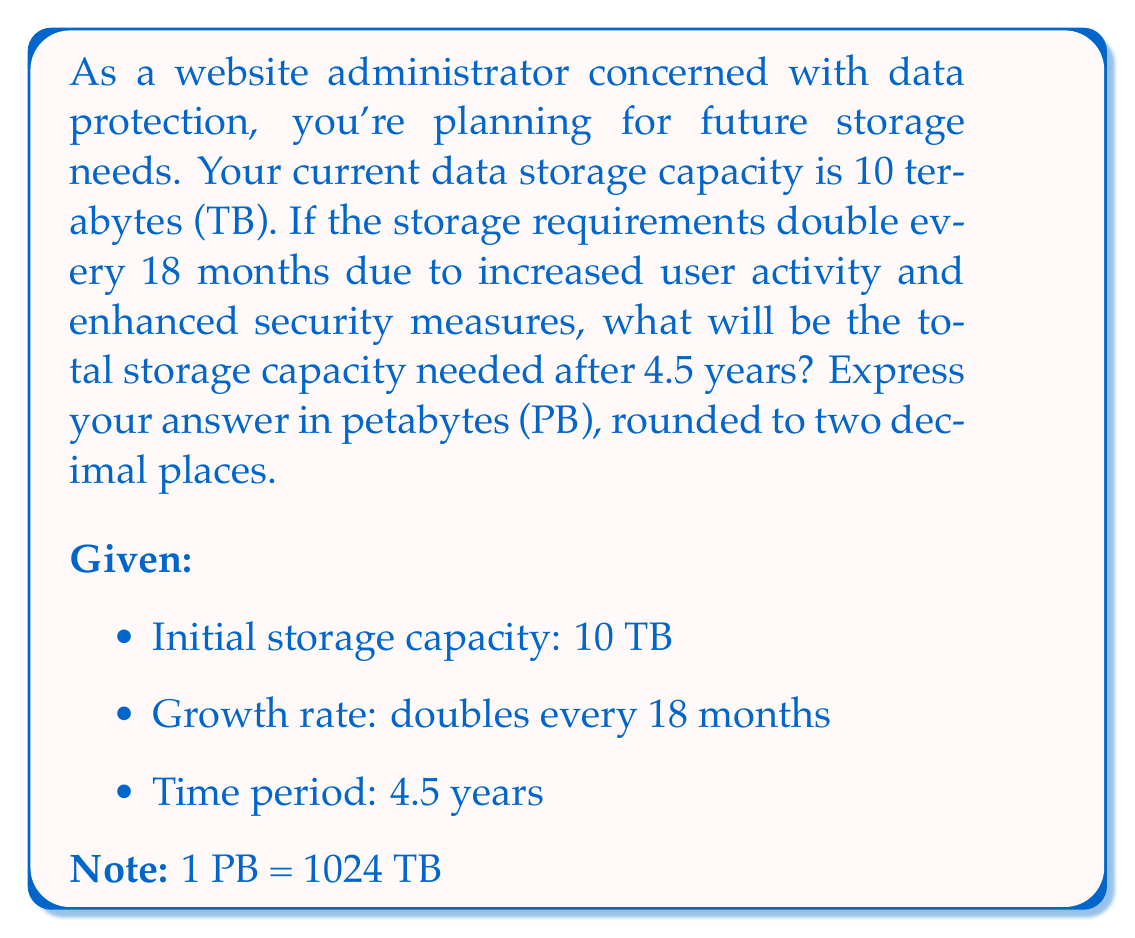Give your solution to this math problem. Let's approach this step-by-step:

1) First, we need to determine how many 18-month periods are in 4.5 years:
   $$ \text{Number of periods} = \frac{4.5 \text{ years}}{1.5 \text{ years}} = 3 $$

2) Now, we can set up our exponential growth function:
   $$ C = C_0 \cdot 2^n $$
   Where:
   $C$ is the final capacity
   $C_0$ is the initial capacity (10 TB)
   $n$ is the number of 18-month periods (3)

3) Let's plug in our values:
   $$ C = 10 \cdot 2^3 $$

4) Calculate:
   $$ C = 10 \cdot 8 = 80 \text{ TB} $$

5) Convert TB to PB:
   $$ 80 \text{ TB} = \frac{80}{1024} \text{ PB} \approx 0.078125 \text{ PB} $$

6) Rounding to two decimal places:
   $$ 0.08 \text{ PB} $$
Answer: 0.08 PB 